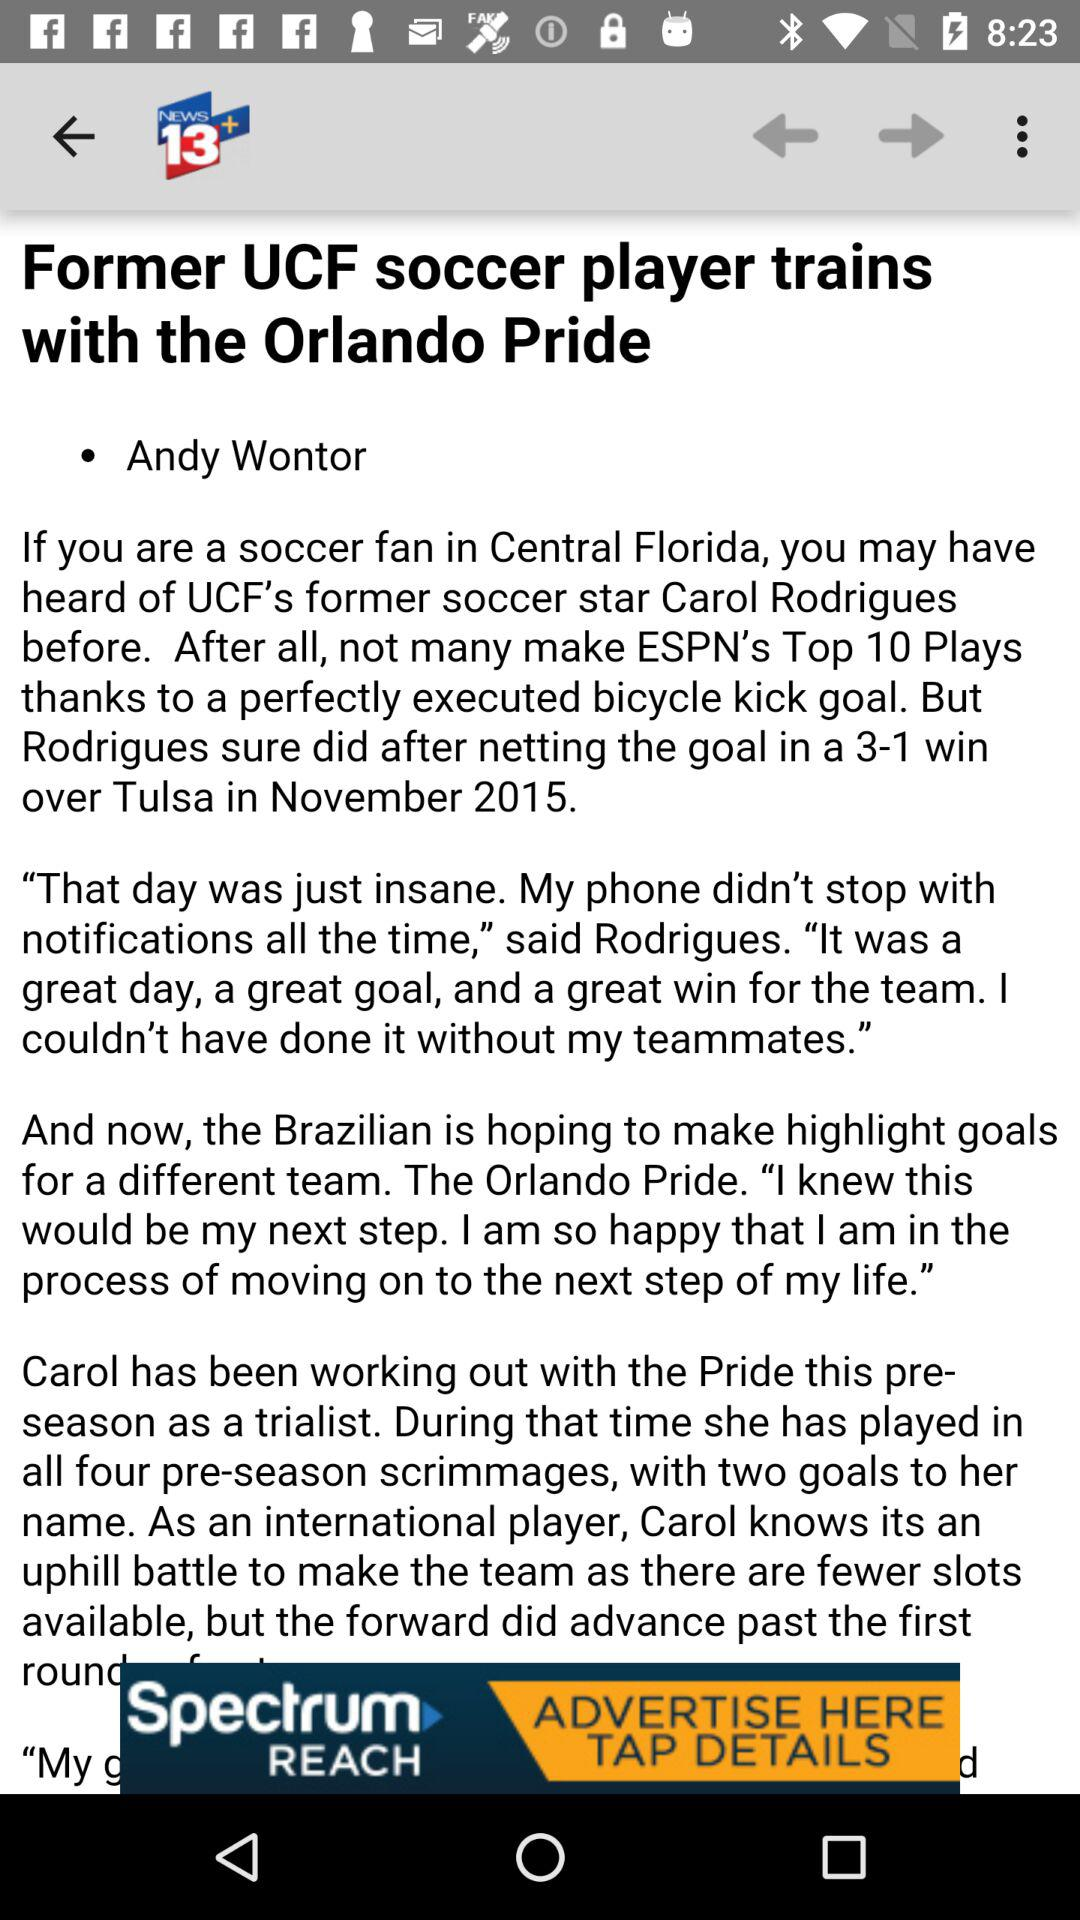How many goals did Carol Rodrigues score during the pre-season?
Answer the question using a single word or phrase. 2 